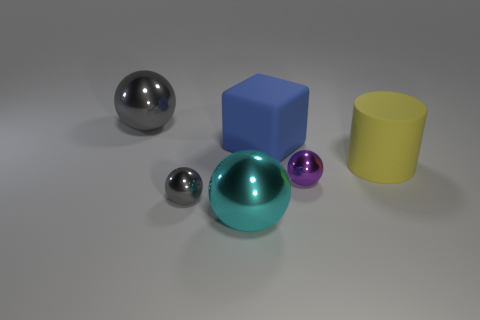There is a tiny object that is left of the cyan metallic sphere; does it have the same color as the large metallic sphere behind the big yellow rubber object?
Make the answer very short. Yes. Is the number of large things on the left side of the cube greater than the number of small gray metal balls?
Your answer should be very brief. Yes. What shape is the large thing that is the same material as the yellow cylinder?
Ensure brevity in your answer.  Cube. There is a ball to the right of the cyan shiny object; does it have the same size as the small gray metallic thing?
Provide a short and direct response. Yes. There is a metallic object behind the matte thing that is on the right side of the block; what is its shape?
Ensure brevity in your answer.  Sphere. What is the size of the cyan ball that is to the right of the large metallic object that is behind the cyan metallic ball?
Offer a very short reply. Large. There is a big sphere left of the cyan thing; what is its color?
Your response must be concise. Gray. What is the size of the cylinder that is the same material as the blue thing?
Your answer should be compact. Large. What number of large yellow objects are the same shape as the tiny gray metal object?
Provide a short and direct response. 0. There is a yellow thing that is the same size as the blue rubber cube; what material is it?
Ensure brevity in your answer.  Rubber. 